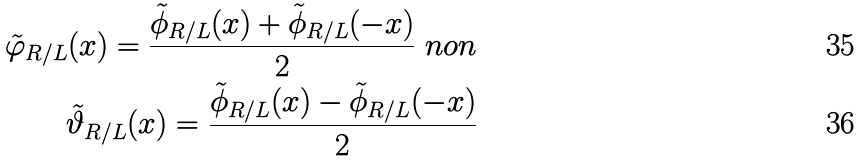Convert formula to latex. <formula><loc_0><loc_0><loc_500><loc_500>\tilde { \varphi } _ { R / L } ( x ) = \frac { \tilde { \phi } _ { R / L } ( x ) + \tilde { \phi } _ { R / L } ( - x ) } { 2 } \ n o n \\ \quad \tilde { \vartheta } _ { R / L } ( x ) = \frac { \tilde { \phi } _ { R / L } ( x ) - \tilde { \phi } _ { R / L } ( - x ) } { 2 }</formula> 